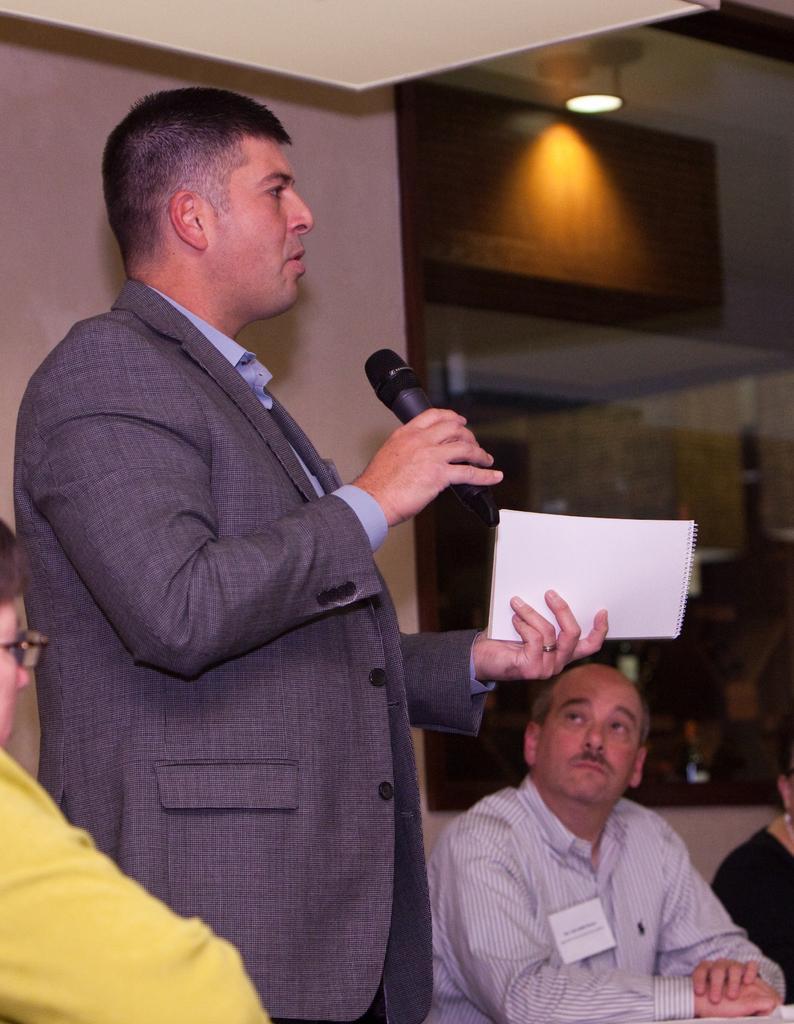Could you give a brief overview of what you see in this image? Here a person is standing and talking on mic holding a book in other hand. There are few people around him sitting on the chair. 